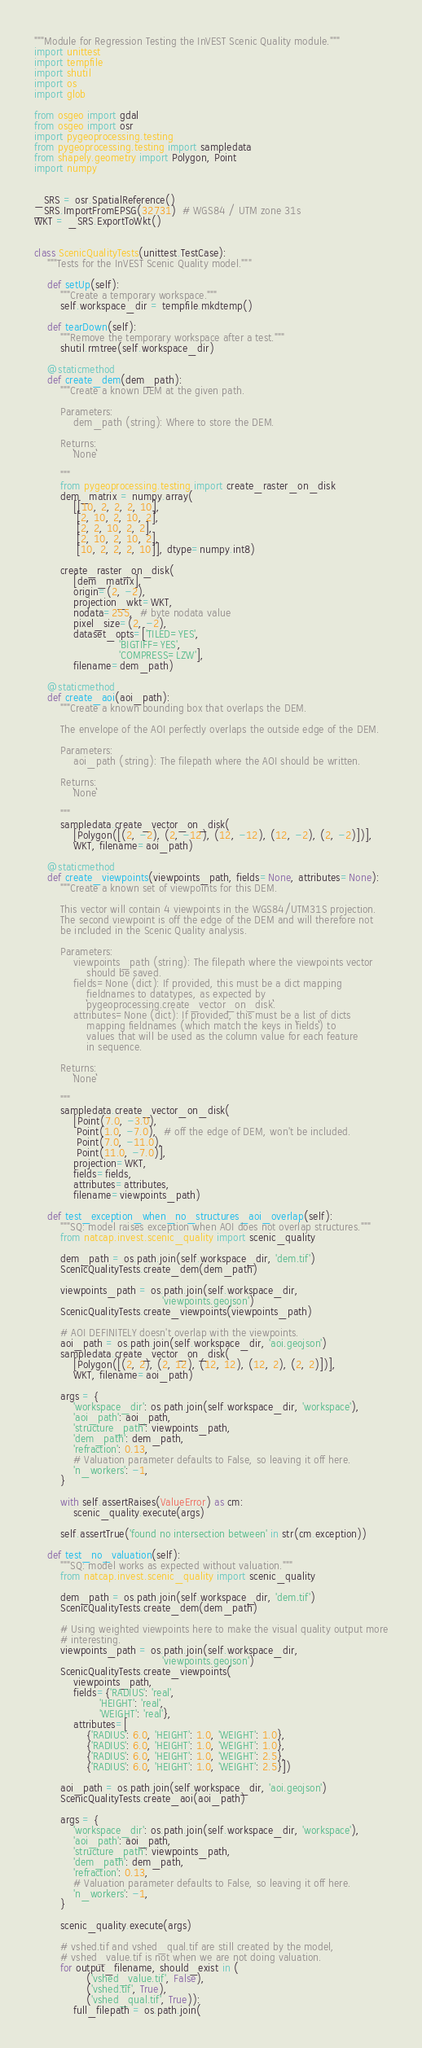Convert code to text. <code><loc_0><loc_0><loc_500><loc_500><_Python_>"""Module for Regression Testing the InVEST Scenic Quality module."""
import unittest
import tempfile
import shutil
import os
import glob

from osgeo import gdal
from osgeo import osr
import pygeoprocessing.testing
from pygeoprocessing.testing import sampledata
from shapely.geometry import Polygon, Point
import numpy


_SRS = osr.SpatialReference()
_SRS.ImportFromEPSG(32731)  # WGS84 / UTM zone 31s
WKT = _SRS.ExportToWkt()


class ScenicQualityTests(unittest.TestCase):
    """Tests for the InVEST Scenic Quality model."""

    def setUp(self):
        """Create a temporary workspace."""
        self.workspace_dir = tempfile.mkdtemp()

    def tearDown(self):
        """Remove the temporary workspace after a test."""
        shutil.rmtree(self.workspace_dir)

    @staticmethod
    def create_dem(dem_path):
        """Create a known DEM at the given path.

        Parameters:
            dem_path (string): Where to store the DEM.

        Returns:
            ``None``

        """
        from pygeoprocessing.testing import create_raster_on_disk
        dem_matrix = numpy.array(
            [[10, 2, 2, 2, 10],
             [2, 10, 2, 10, 2],
             [2, 2, 10, 2, 2],
             [2, 10, 2, 10, 2],
             [10, 2, 2, 2, 10]], dtype=numpy.int8)

        create_raster_on_disk(
            [dem_matrix],
            origin=(2, -2),
            projection_wkt=WKT,
            nodata=255,  # byte nodata value
            pixel_size=(2, -2),
            dataset_opts=['TILED=YES',
                          'BIGTIFF=YES',
                          'COMPRESS=LZW'],
            filename=dem_path)

    @staticmethod
    def create_aoi(aoi_path):
        """Create a known bounding box that overlaps the DEM.

        The envelope of the AOI perfectly overlaps the outside edge of the DEM.

        Parameters:
            aoi_path (string): The filepath where the AOI should be written.

        Returns:
            ``None``

        """
        sampledata.create_vector_on_disk(
            [Polygon([(2, -2), (2, -12), (12, -12), (12, -2), (2, -2)])],
            WKT, filename=aoi_path)

    @staticmethod
    def create_viewpoints(viewpoints_path, fields=None, attributes=None):
        """Create a known set of viewpoints for this DEM.

        This vector will contain 4 viewpoints in the WGS84/UTM31S projection.
        The second viewpoint is off the edge of the DEM and will therefore not
        be included in the Scenic Quality analysis.

        Parameters:
            viewpoints_path (string): The filepath where the viewpoints vector
                should be saved.
            fields=None (dict): If provided, this must be a dict mapping
                fieldnames to datatypes, as expected by
                ``pygeoprocessing.create_vector_on_disk``.
            attributes=None (dict): If provided, this must be a list of dicts
                mapping fieldnames (which match the keys in ``fields``) to
                values that will be used as the column value for each feature
                in sequence.

        Returns:
            ``None``

        """
        sampledata.create_vector_on_disk(
            [Point(7.0, -3.0),
             Point(1.0, -7.0),  # off the edge of DEM, won't be included.
             Point(7.0, -11.0),
             Point(11.0, -7.0)],
            projection=WKT,
            fields=fields,
            attributes=attributes,
            filename=viewpoints_path)

    def test_exception_when_no_structures_aoi_overlap(self):
        """SQ: model raises exception when AOI does not overlap structures."""
        from natcap.invest.scenic_quality import scenic_quality

        dem_path = os.path.join(self.workspace_dir, 'dem.tif')
        ScenicQualityTests.create_dem(dem_path)

        viewpoints_path = os.path.join(self.workspace_dir,
                                       'viewpoints.geojson')
        ScenicQualityTests.create_viewpoints(viewpoints_path)

        # AOI DEFINITELY doesn't overlap with the viewpoints.
        aoi_path = os.path.join(self.workspace_dir, 'aoi.geojson')
        sampledata.create_vector_on_disk(
            [Polygon([(2, 2), (2, 12), (12, 12), (12, 2), (2, 2)])],
            WKT, filename=aoi_path)

        args = {
            'workspace_dir': os.path.join(self.workspace_dir, 'workspace'),
            'aoi_path': aoi_path,
            'structure_path': viewpoints_path,
            'dem_path': dem_path,
            'refraction': 0.13,
            # Valuation parameter defaults to False, so leaving it off here.
            'n_workers': -1,
        }

        with self.assertRaises(ValueError) as cm:
            scenic_quality.execute(args)

        self.assertTrue('found no intersection between' in str(cm.exception))

    def test_no_valuation(self):
        """SQ: model works as expected without valuation."""
        from natcap.invest.scenic_quality import scenic_quality

        dem_path = os.path.join(self.workspace_dir, 'dem.tif')
        ScenicQualityTests.create_dem(dem_path)

        # Using weighted viewpoints here to make the visual quality output more
        # interesting.
        viewpoints_path = os.path.join(self.workspace_dir,
                                       'viewpoints.geojson')
        ScenicQualityTests.create_viewpoints(
            viewpoints_path,
            fields={'RADIUS': 'real',
                    'HEIGHT': 'real',
                    'WEIGHT': 'real'},
            attributes=[
                {'RADIUS': 6.0, 'HEIGHT': 1.0, 'WEIGHT': 1.0},
                {'RADIUS': 6.0, 'HEIGHT': 1.0, 'WEIGHT': 1.0},
                {'RADIUS': 6.0, 'HEIGHT': 1.0, 'WEIGHT': 2.5},
                {'RADIUS': 6.0, 'HEIGHT': 1.0, 'WEIGHT': 2.5}])

        aoi_path = os.path.join(self.workspace_dir, 'aoi.geojson')
        ScenicQualityTests.create_aoi(aoi_path)

        args = {
            'workspace_dir': os.path.join(self.workspace_dir, 'workspace'),
            'aoi_path': aoi_path,
            'structure_path': viewpoints_path,
            'dem_path': dem_path,
            'refraction': 0.13,
            # Valuation parameter defaults to False, so leaving it off here.
            'n_workers': -1,
        }

        scenic_quality.execute(args)

        # vshed.tif and vshed_qual.tif are still created by the model,
        # vshed_value.tif is not when we are not doing valuation.
        for output_filename, should_exist in (
                ('vshed_value.tif', False),
                ('vshed.tif', True),
                ('vshed_qual.tif', True)):
            full_filepath = os.path.join(</code> 